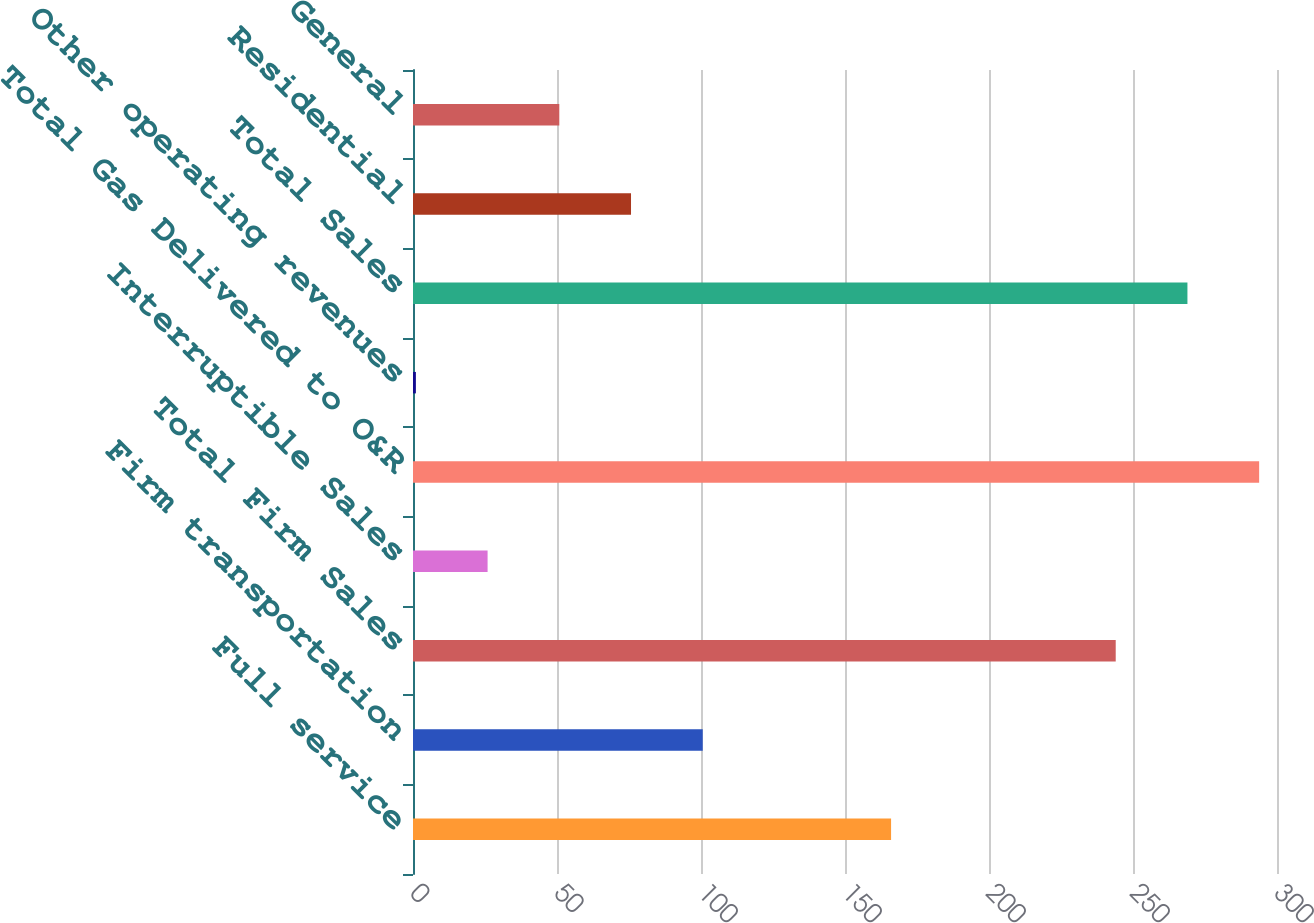<chart> <loc_0><loc_0><loc_500><loc_500><bar_chart><fcel>Full service<fcel>Firm transportation<fcel>Total Firm Sales<fcel>Interruptible Sales<fcel>Total Gas Delivered to O&R<fcel>Other operating revenues<fcel>Total Sales<fcel>Residential<fcel>General<nl><fcel>166<fcel>100.6<fcel>244<fcel>25.9<fcel>293.8<fcel>1<fcel>268.9<fcel>75.7<fcel>50.8<nl></chart> 